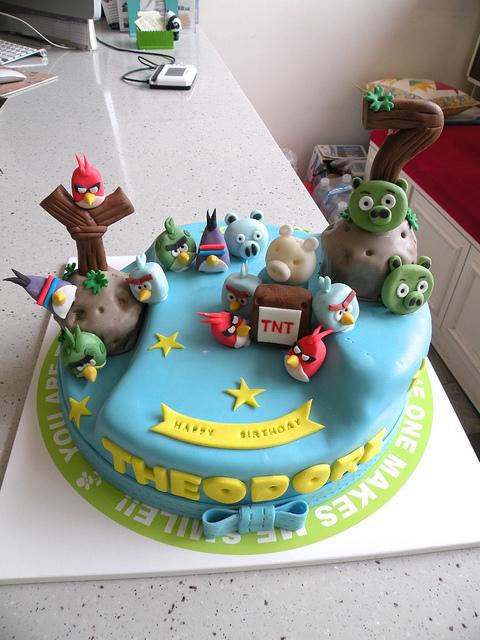What are the yellow letters on the side of the cake?
Concise answer only. Theodore. What color is the wall?
Keep it brief. White. What game are the characters on the cake from?
Give a very brief answer. Angry birds. 